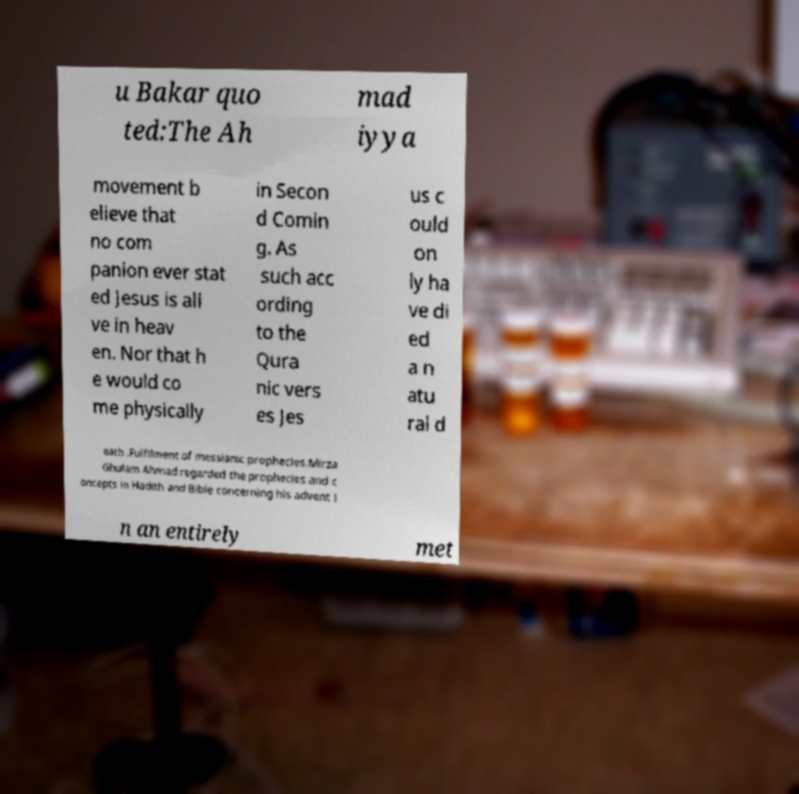I need the written content from this picture converted into text. Can you do that? u Bakar quo ted:The Ah mad iyya movement b elieve that no com panion ever stat ed Jesus is ali ve in heav en. Nor that h e would co me physically in Secon d Comin g. As such acc ording to the Qura nic vers es Jes us c ould on ly ha ve di ed a n atu ral d eath .Fulfilment of messianic prophecies.Mirza Ghulam Ahmad regarded the prophecies and c oncepts in Hadith and Bible concerning his advent i n an entirely met 